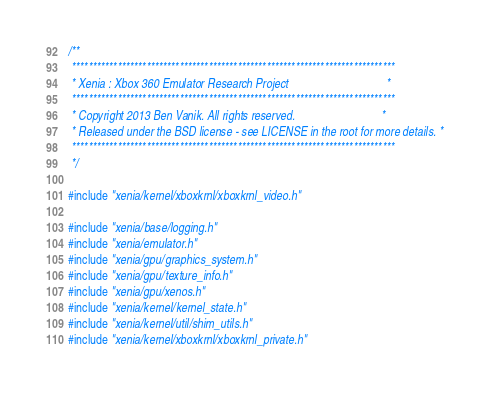Convert code to text. <code><loc_0><loc_0><loc_500><loc_500><_C++_>/**
 ******************************************************************************
 * Xenia : Xbox 360 Emulator Research Project                                 *
 ******************************************************************************
 * Copyright 2013 Ben Vanik. All rights reserved.                             *
 * Released under the BSD license - see LICENSE in the root for more details. *
 ******************************************************************************
 */

#include "xenia/kernel/xboxkrnl/xboxkrnl_video.h"

#include "xenia/base/logging.h"
#include "xenia/emulator.h"
#include "xenia/gpu/graphics_system.h"
#include "xenia/gpu/texture_info.h"
#include "xenia/gpu/xenos.h"
#include "xenia/kernel/kernel_state.h"
#include "xenia/kernel/util/shim_utils.h"
#include "xenia/kernel/xboxkrnl/xboxkrnl_private.h"</code> 